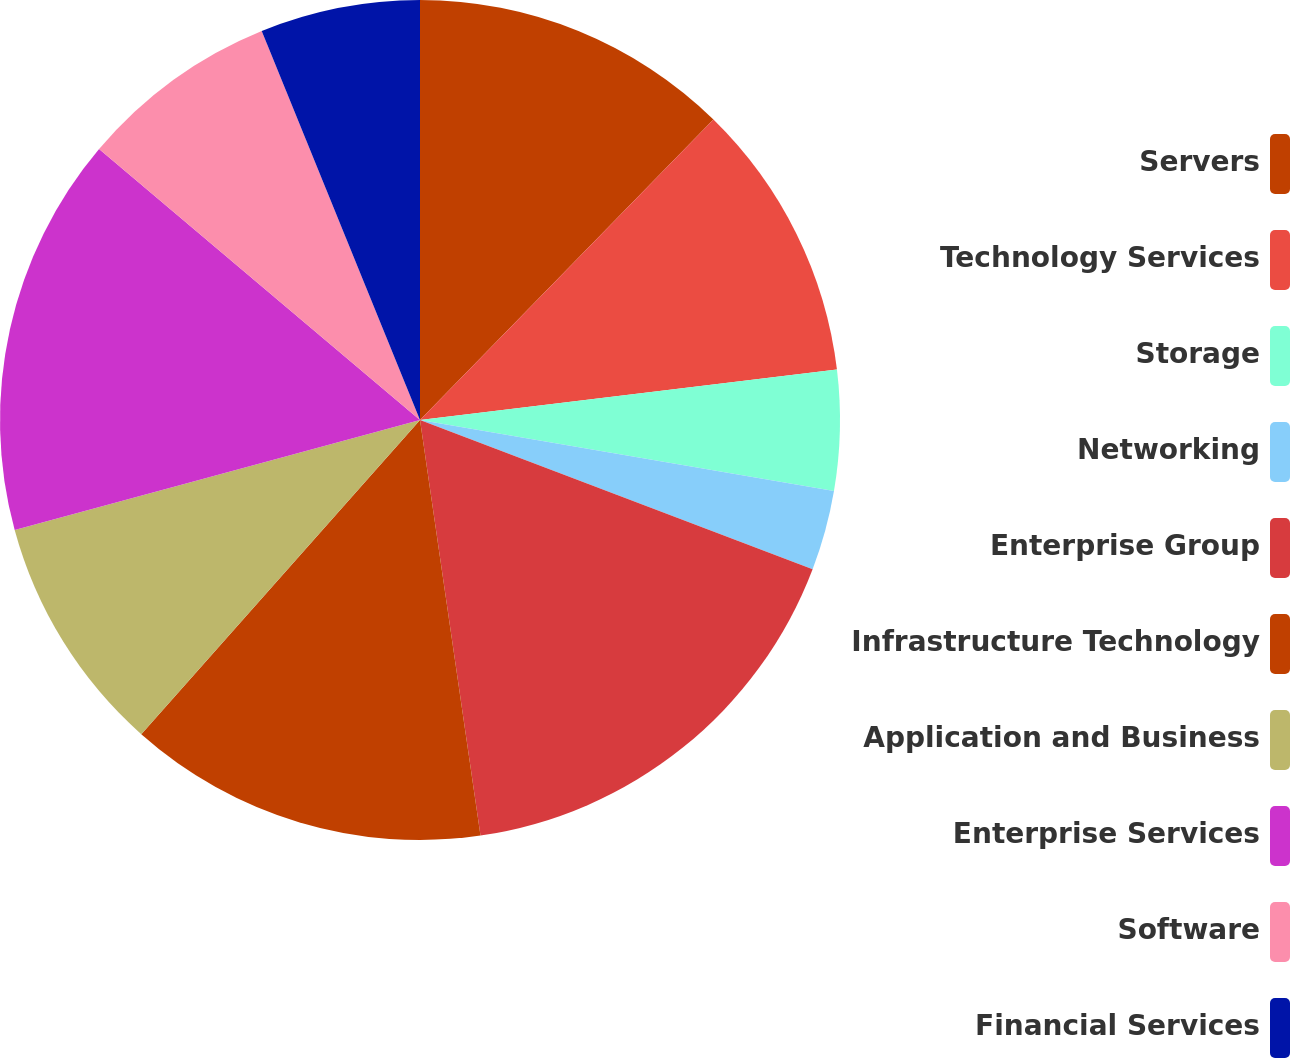Convert chart to OTSL. <chart><loc_0><loc_0><loc_500><loc_500><pie_chart><fcel>Servers<fcel>Technology Services<fcel>Storage<fcel>Networking<fcel>Enterprise Group<fcel>Infrastructure Technology<fcel>Application and Business<fcel>Enterprise Services<fcel>Software<fcel>Financial Services<nl><fcel>12.31%<fcel>10.77%<fcel>4.62%<fcel>3.08%<fcel>16.92%<fcel>13.85%<fcel>9.23%<fcel>15.38%<fcel>7.69%<fcel>6.15%<nl></chart> 